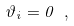<formula> <loc_0><loc_0><loc_500><loc_500>\vartheta _ { i } = 0 \ ,</formula> 